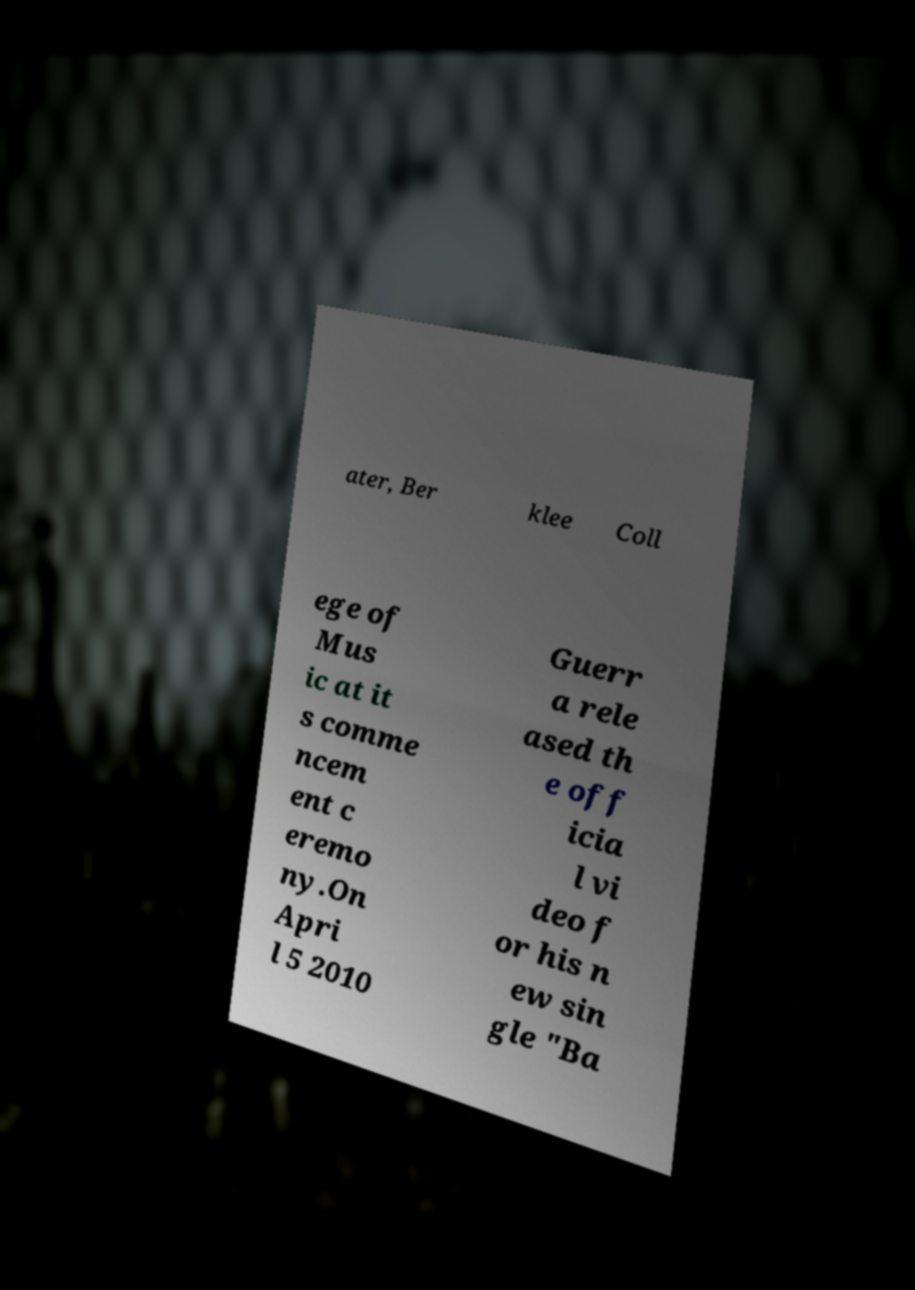Could you assist in decoding the text presented in this image and type it out clearly? ater, Ber klee Coll ege of Mus ic at it s comme ncem ent c eremo ny.On Apri l 5 2010 Guerr a rele ased th e off icia l vi deo f or his n ew sin gle "Ba 